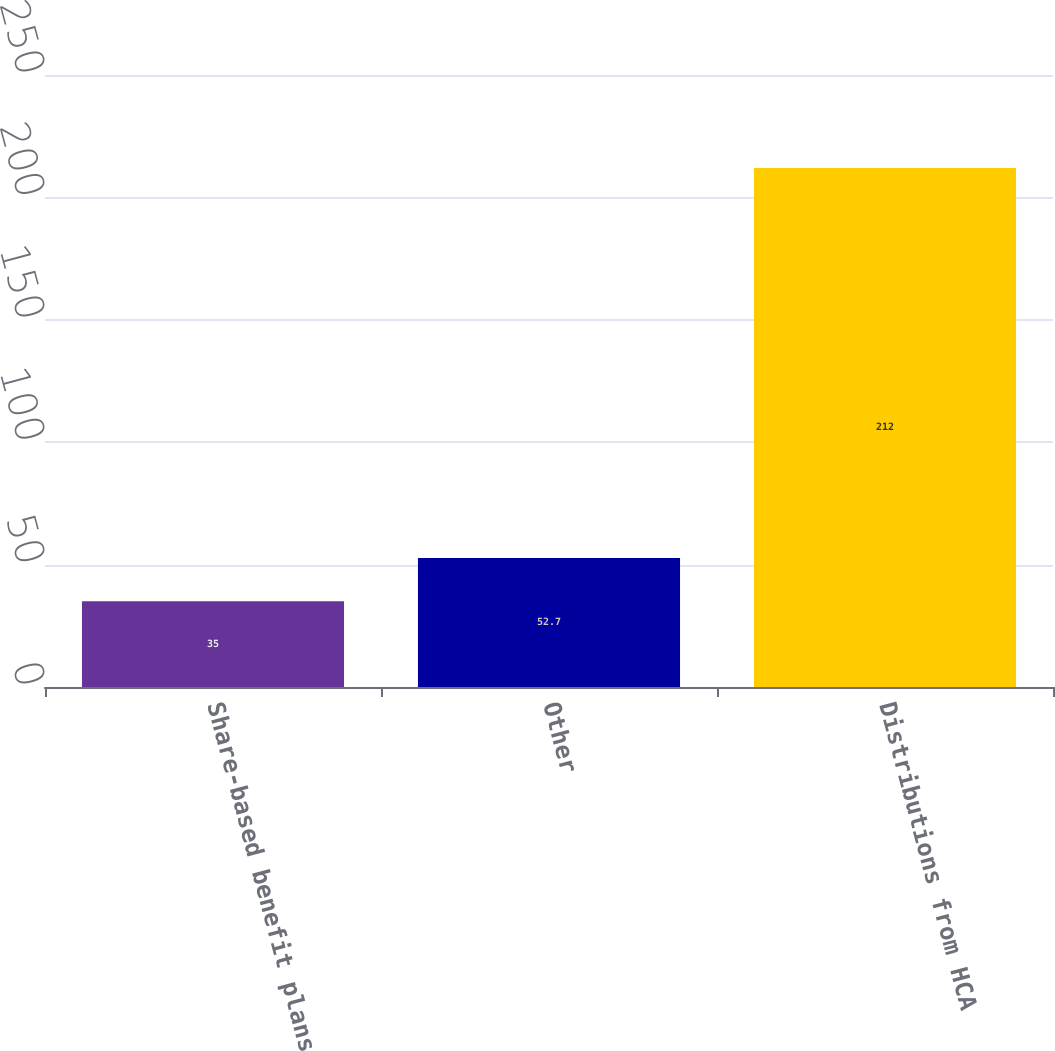Convert chart to OTSL. <chart><loc_0><loc_0><loc_500><loc_500><bar_chart><fcel>Share-based benefit plans<fcel>Other<fcel>Distributions from HCA<nl><fcel>35<fcel>52.7<fcel>212<nl></chart> 